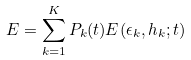Convert formula to latex. <formula><loc_0><loc_0><loc_500><loc_500>E = \sum _ { k = 1 } ^ { K } P _ { k } ( t ) E ( \epsilon _ { k } , h _ { k } ; t )</formula> 